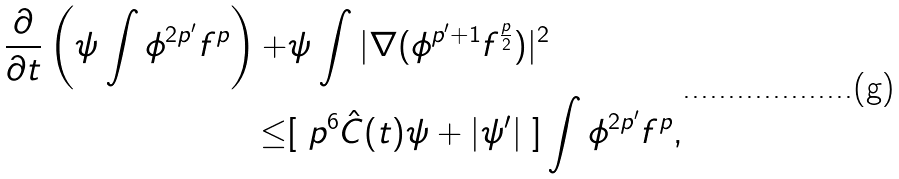<formula> <loc_0><loc_0><loc_500><loc_500>\frac { \partial } { \partial t } \left ( \psi \int \phi ^ { 2 p ^ { \prime } } f ^ { p } \right ) + & \psi \int | \nabla ( \phi ^ { p ^ { \prime } + 1 } f ^ { \frac { p } { 2 } } ) | ^ { 2 } \\ \leq & [ \ p ^ { 6 } \hat { C } ( t ) \psi + | \psi ^ { \prime } | \ ] \int \phi ^ { 2 p ^ { \prime } } f ^ { p } ,</formula> 